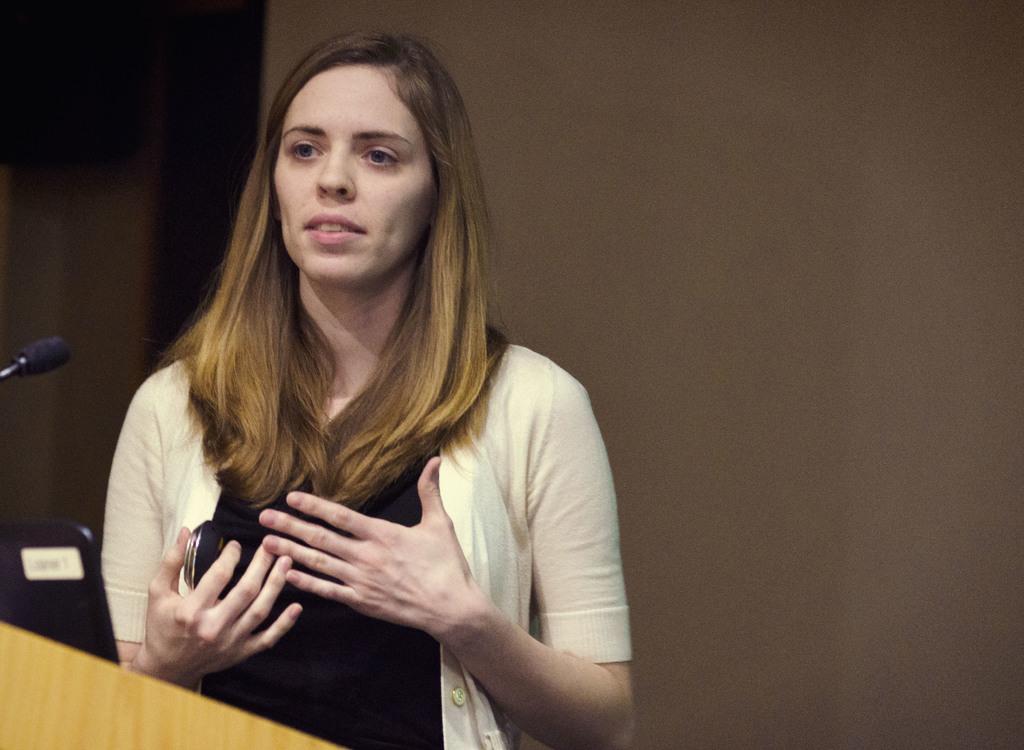How would you summarize this image in a sentence or two? In this picture there is a lady on the left side of the image and there is a desk and a mic in front of her. 